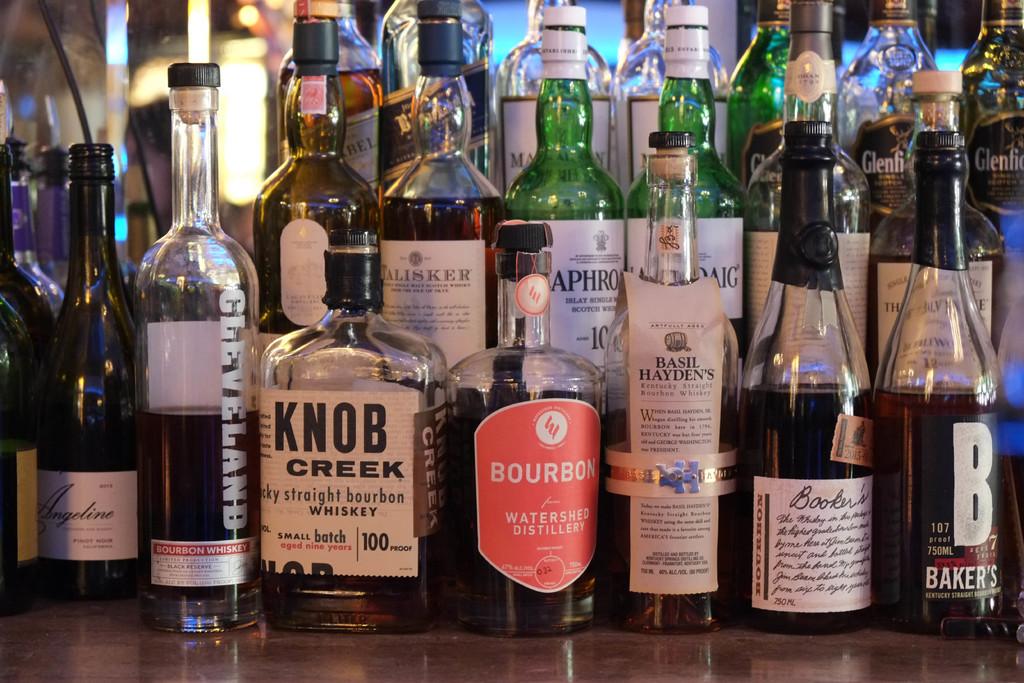What's the brand of the whiskey in the short bottle with a white label?
Make the answer very short. Knob creek. What is the name of the alcohol in the bottle with a red label?
Ensure brevity in your answer.  Bourbon. 